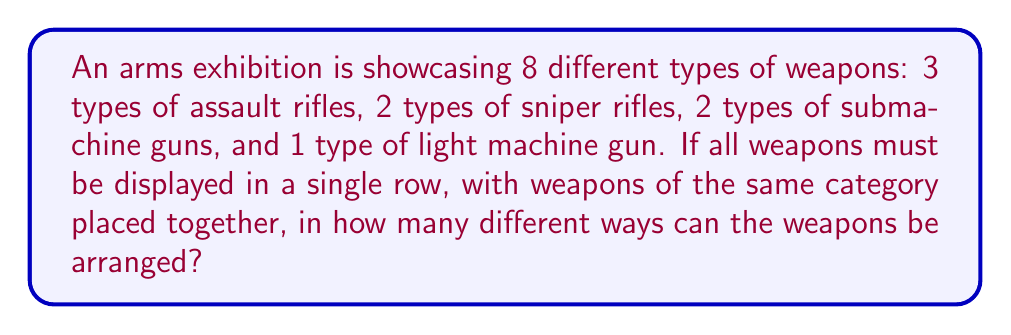Give your solution to this math problem. Let's approach this problem step by step:

1) First, we need to consider the arrangement of the weapon categories. We have 4 categories (assault rifles, sniper rifles, submachine guns, and light machine gun), so we need to calculate the number of ways to arrange these 4 categories:

   $$4! = 4 \times 3 \times 2 \times 1 = 24$$

2) Now, within each category, we need to consider the arrangements of individual weapons:

   - Assault rifles: 3! = 6 ways
   - Sniper rifles: 2! = 2 ways
   - Submachine guns: 2! = 2 ways
   - Light machine gun: 1! = 1 way (only one arrangement possible)

3) According to the multiplication principle, we multiply all these numbers together:

   $$24 \times 6 \times 2 \times 2 \times 1 = 576$$

This calculation gives us the total number of possible arrangements, considering both the order of categories and the order of weapons within each category.
Answer: 576 ways 